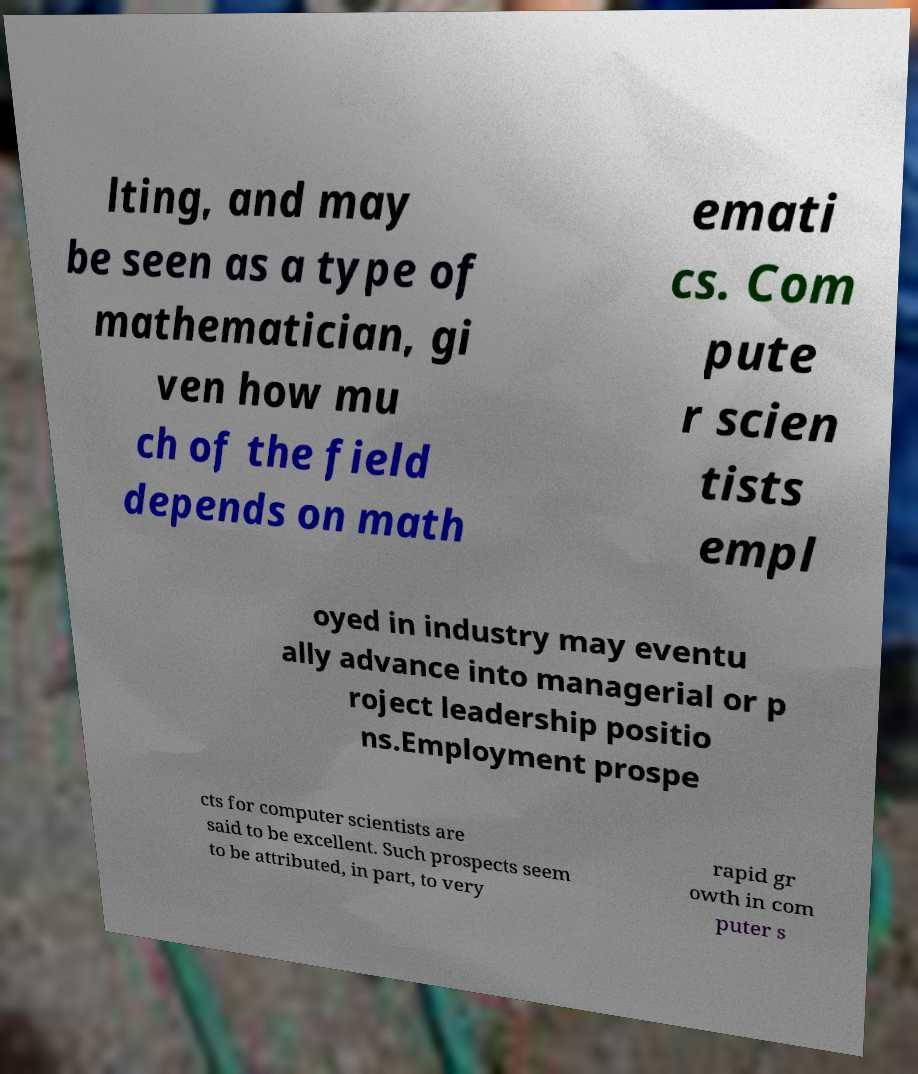Can you accurately transcribe the text from the provided image for me? lting, and may be seen as a type of mathematician, gi ven how mu ch of the field depends on math emati cs. Com pute r scien tists empl oyed in industry may eventu ally advance into managerial or p roject leadership positio ns.Employment prospe cts for computer scientists are said to be excellent. Such prospects seem to be attributed, in part, to very rapid gr owth in com puter s 